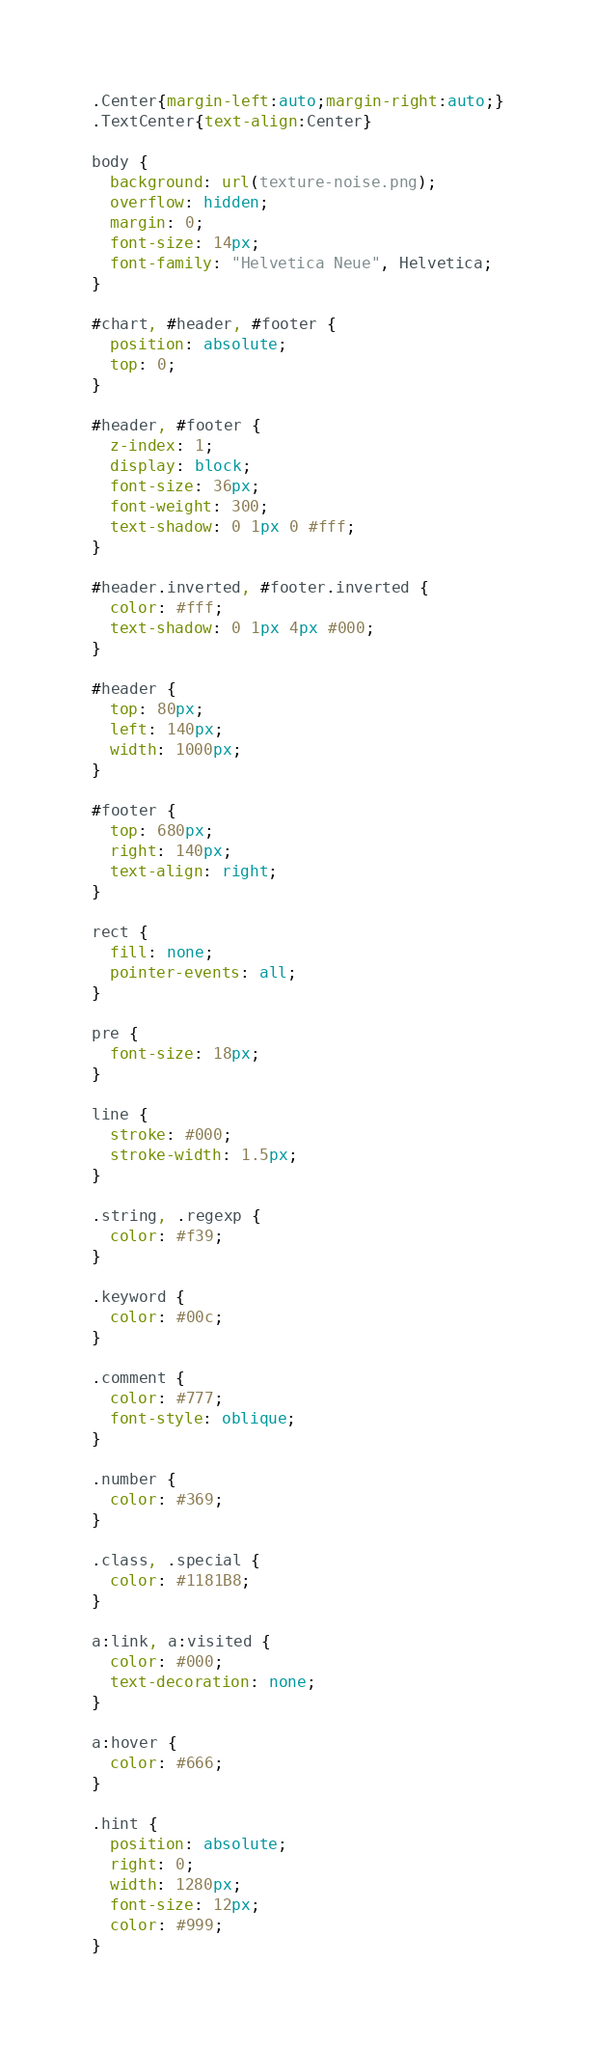Convert code to text. <code><loc_0><loc_0><loc_500><loc_500><_CSS_>.Center{margin-left:auto;margin-right:auto;}
.TextCenter{text-align:Center}

body {
  background: url(texture-noise.png);
  overflow: hidden;
  margin: 0;
  font-size: 14px;
  font-family: "Helvetica Neue", Helvetica;
}

#chart, #header, #footer {
  position: absolute;
  top: 0;
}

#header, #footer {
  z-index: 1;
  display: block;
  font-size: 36px;
  font-weight: 300;
  text-shadow: 0 1px 0 #fff;
}

#header.inverted, #footer.inverted {
  color: #fff;
  text-shadow: 0 1px 4px #000;
}

#header {
  top: 80px;
  left: 140px;
  width: 1000px;
}

#footer {
  top: 680px;
  right: 140px;
  text-align: right;
}

rect {
  fill: none;
  pointer-events: all;
}

pre {
  font-size: 18px;
}

line {
  stroke: #000;
  stroke-width: 1.5px;
}

.string, .regexp {
  color: #f39;
}

.keyword {
  color: #00c;
}

.comment {
  color: #777;
  font-style: oblique;
}

.number {
  color: #369;
}

.class, .special {
  color: #1181B8;
}

a:link, a:visited {
  color: #000;
  text-decoration: none;
}

a:hover {
  color: #666;
}

.hint {
  position: absolute;
  right: 0;
  width: 1280px;
  font-size: 12px;
  color: #999;
}</code> 